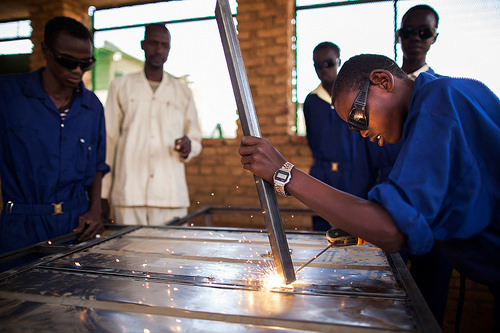<image>
Is the man next to the man? No. The man is not positioned next to the man. They are located in different areas of the scene. 